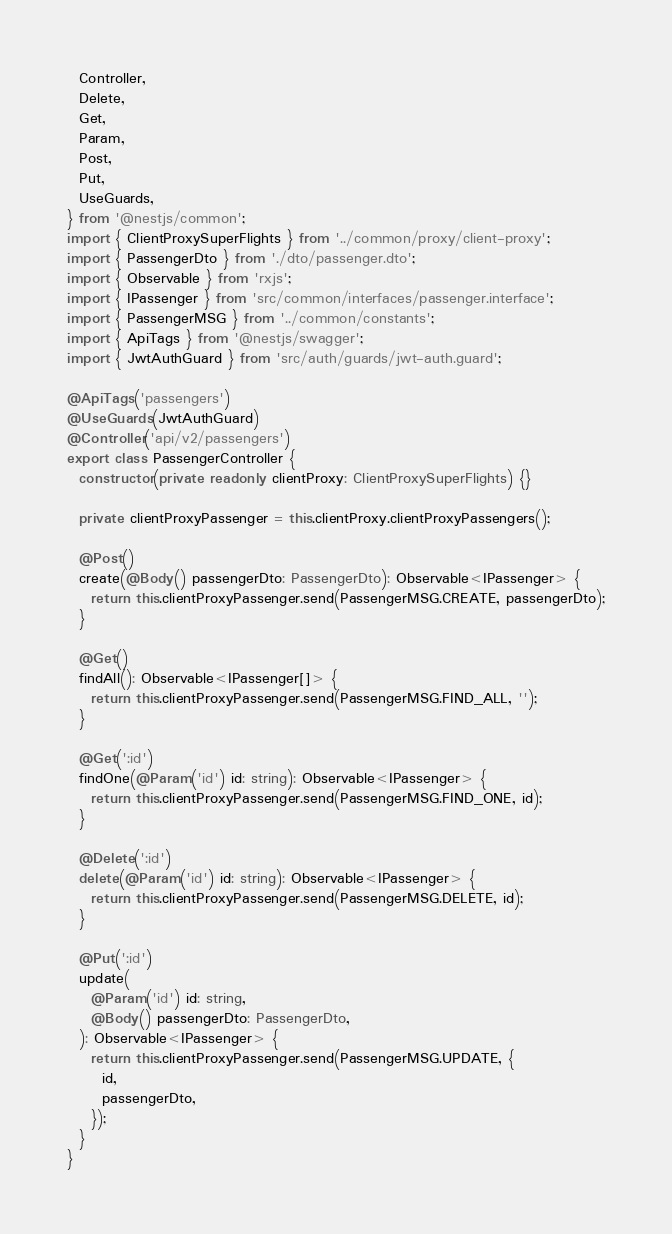<code> <loc_0><loc_0><loc_500><loc_500><_TypeScript_>  Controller,
  Delete,
  Get,
  Param,
  Post,
  Put,
  UseGuards,
} from '@nestjs/common';
import { ClientProxySuperFlights } from '../common/proxy/client-proxy';
import { PassengerDto } from './dto/passenger.dto';
import { Observable } from 'rxjs';
import { IPassenger } from 'src/common/interfaces/passenger.interface';
import { PassengerMSG } from '../common/constants';
import { ApiTags } from '@nestjs/swagger';
import { JwtAuthGuard } from 'src/auth/guards/jwt-auth.guard';

@ApiTags('passengers')
@UseGuards(JwtAuthGuard)
@Controller('api/v2/passengers')
export class PassengerController {
  constructor(private readonly clientProxy: ClientProxySuperFlights) {}

  private clientProxyPassenger = this.clientProxy.clientProxyPassengers();

  @Post()
  create(@Body() passengerDto: PassengerDto): Observable<IPassenger> {
    return this.clientProxyPassenger.send(PassengerMSG.CREATE, passengerDto);
  }

  @Get()
  findAll(): Observable<IPassenger[]> {
    return this.clientProxyPassenger.send(PassengerMSG.FIND_ALL, '');
  }

  @Get(':id')
  findOne(@Param('id') id: string): Observable<IPassenger> {
    return this.clientProxyPassenger.send(PassengerMSG.FIND_ONE, id);
  }

  @Delete(':id')
  delete(@Param('id') id: string): Observable<IPassenger> {
    return this.clientProxyPassenger.send(PassengerMSG.DELETE, id);
  }

  @Put(':id')
  update(
    @Param('id') id: string,
    @Body() passengerDto: PassengerDto,
  ): Observable<IPassenger> {
    return this.clientProxyPassenger.send(PassengerMSG.UPDATE, {
      id,
      passengerDto,
    });
  }
}
</code> 